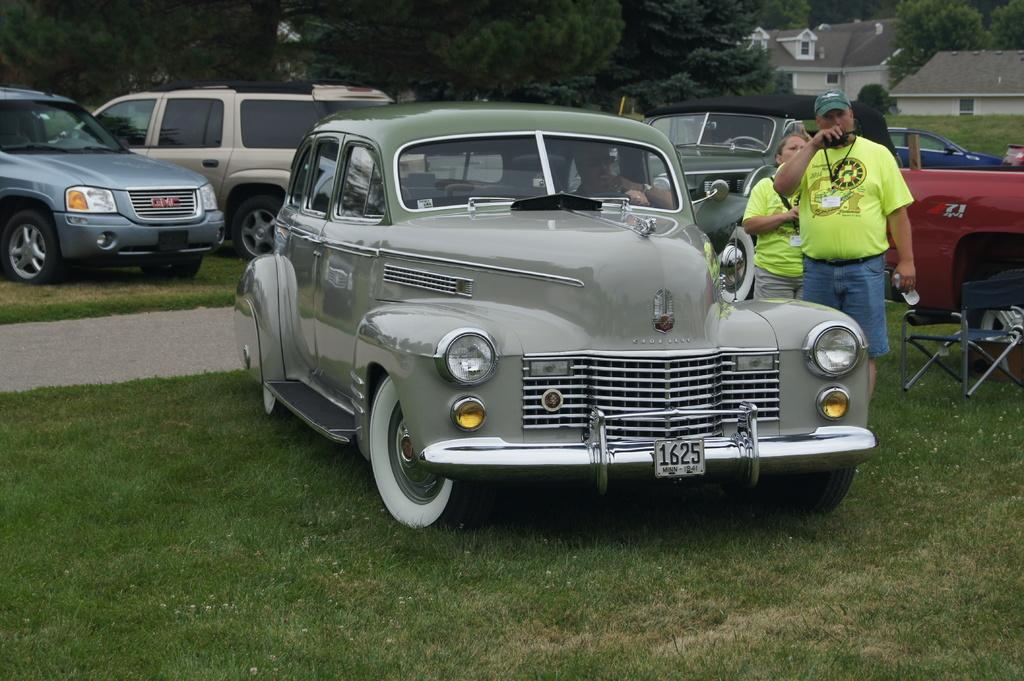What is the main subject of the image? The main subject of the image is many vehicles on the grass. Can you describe the people in the image? There are two people to the right of the image. What is located to the right of the image? There is an object to the right of the image. What can be seen in the background of the image? There are many trees and houses visible in the background of the image. How long does it take for the wire to pass through the minute in the image? There is no wire or minute present in the image. 